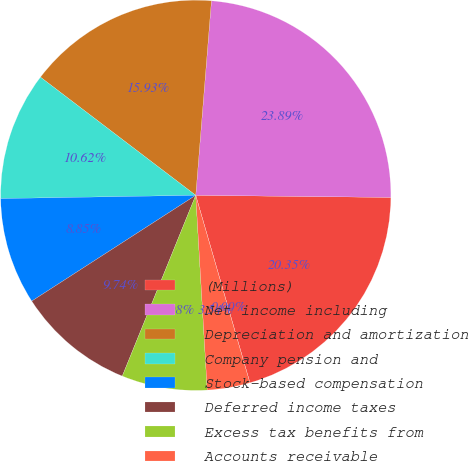Convert chart to OTSL. <chart><loc_0><loc_0><loc_500><loc_500><pie_chart><fcel>(Millions)<fcel>Net income including<fcel>Depreciation and amortization<fcel>Company pension and<fcel>Stock-based compensation<fcel>Deferred income taxes<fcel>Excess tax benefits from<fcel>Accounts receivable<fcel>Inventories<nl><fcel>20.35%<fcel>23.89%<fcel>15.93%<fcel>10.62%<fcel>8.85%<fcel>9.74%<fcel>7.08%<fcel>3.54%<fcel>0.0%<nl></chart> 